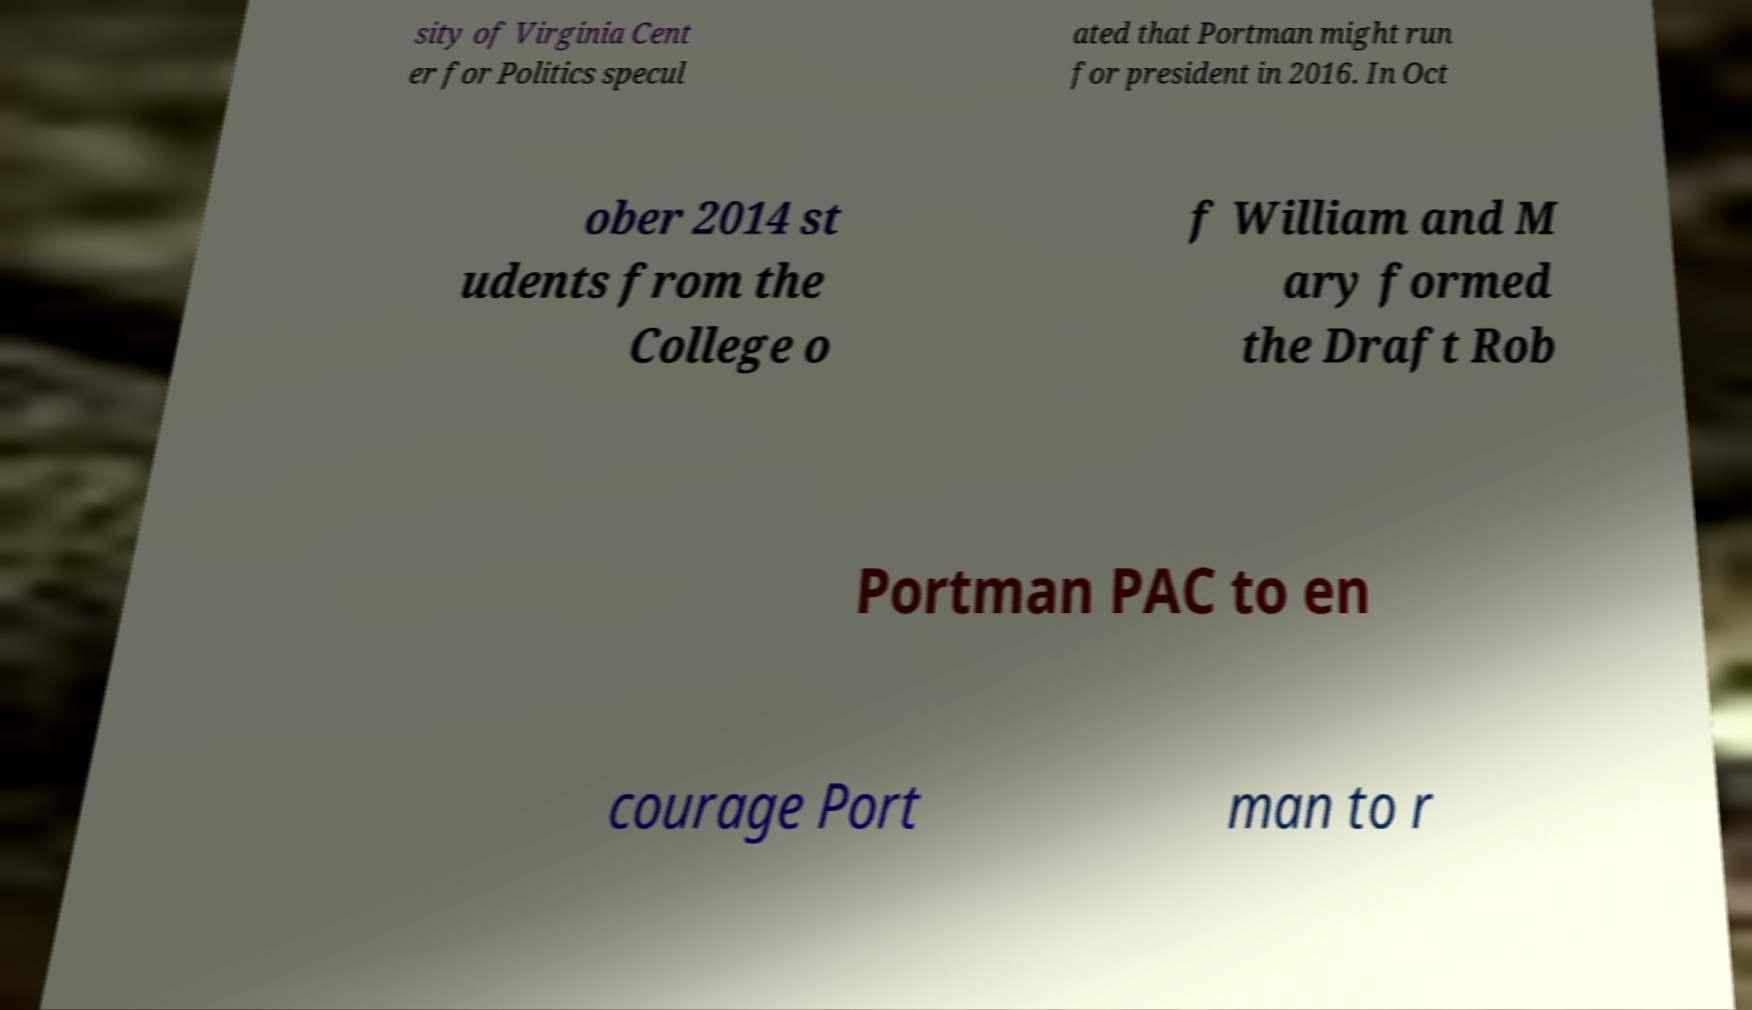For documentation purposes, I need the text within this image transcribed. Could you provide that? sity of Virginia Cent er for Politics specul ated that Portman might run for president in 2016. In Oct ober 2014 st udents from the College o f William and M ary formed the Draft Rob Portman PAC to en courage Port man to r 